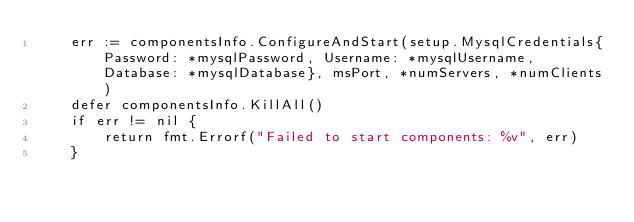Convert code to text. <code><loc_0><loc_0><loc_500><loc_500><_Go_>	err := componentsInfo.ConfigureAndStart(setup.MysqlCredentials{Password: *mysqlPassword, Username: *mysqlUsername, Database: *mysqlDatabase}, msPort, *numServers, *numClients)
	defer componentsInfo.KillAll()
	if err != nil {
		return fmt.Errorf("Failed to start components: %v", err)
	}
</code> 